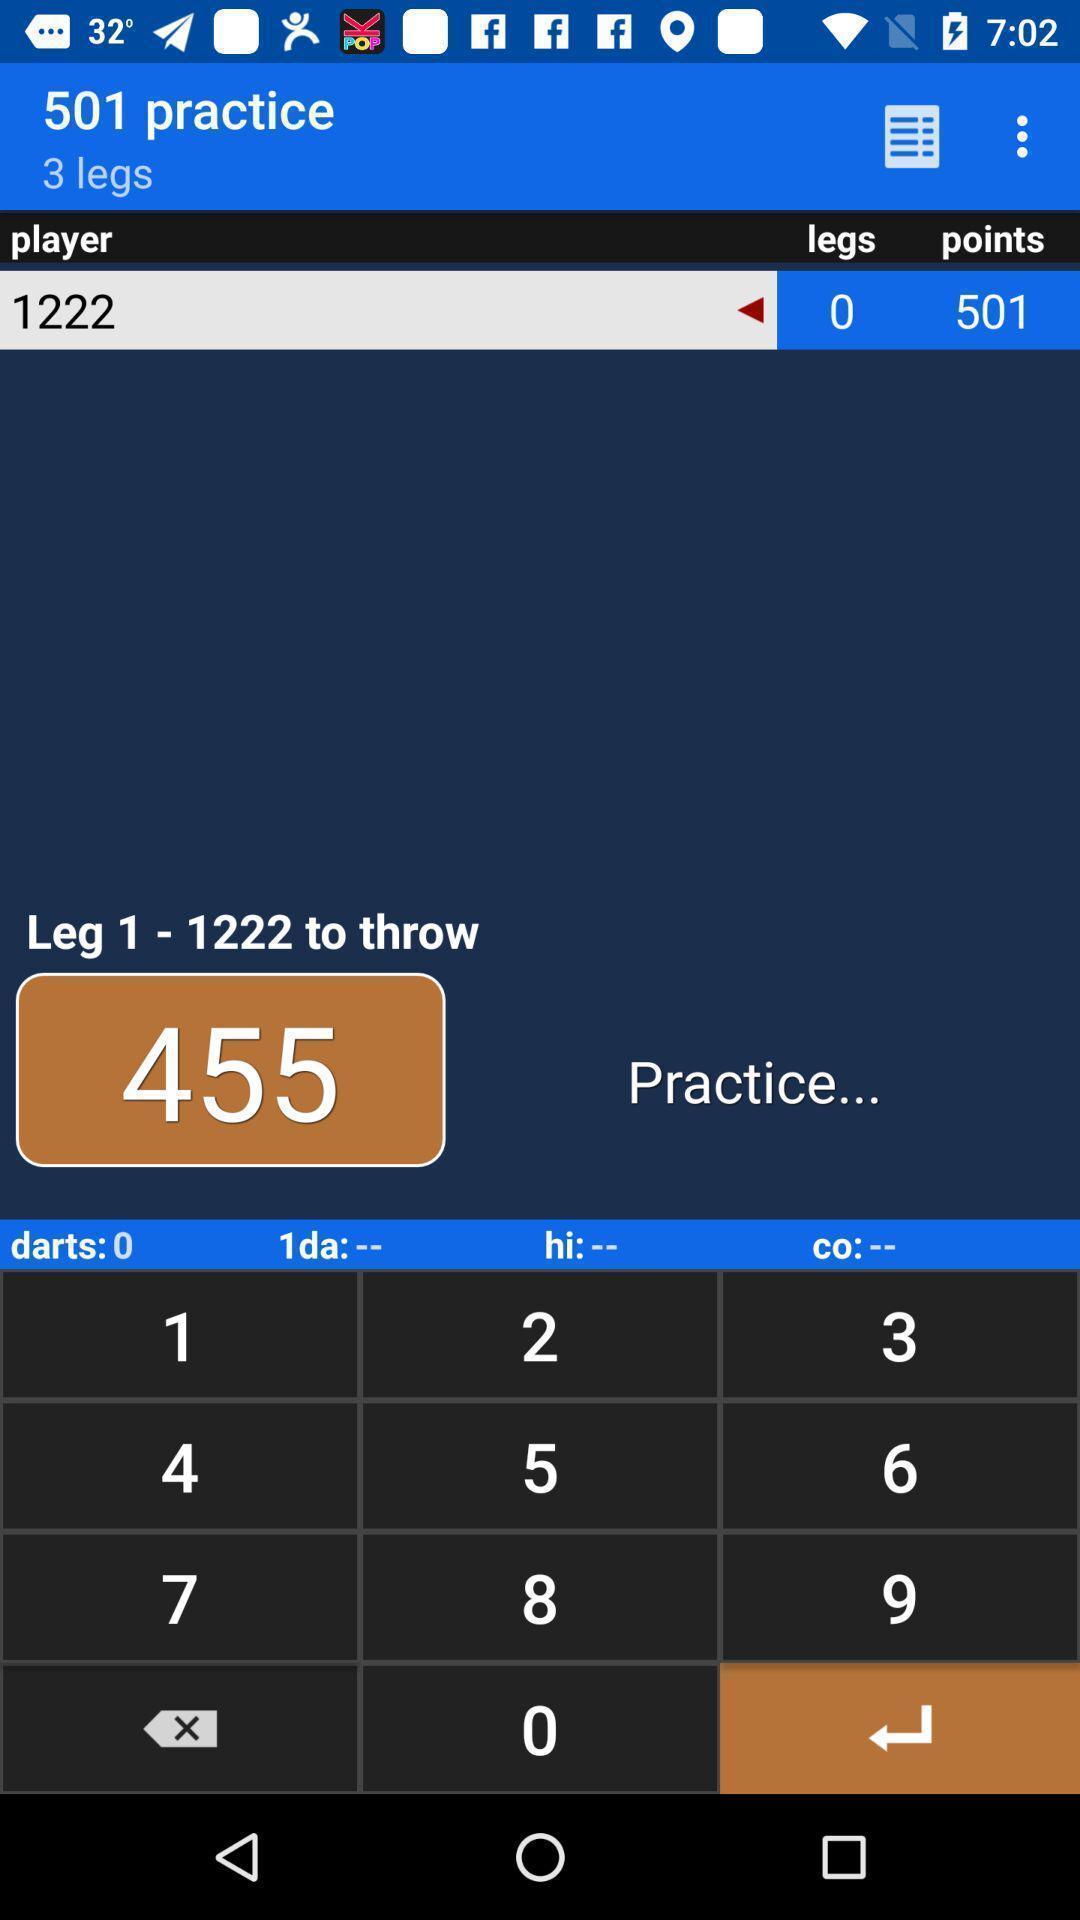Tell me about the visual elements in this screen capture. Screen shows practice page in sports app. 